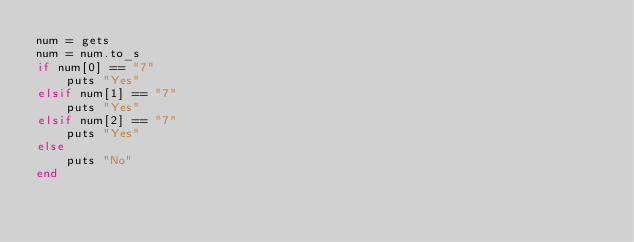<code> <loc_0><loc_0><loc_500><loc_500><_Ruby_>num = gets
num = num.to_s
if num[0] == "7"
    puts "Yes"
elsif num[1] == "7"
    puts "Yes"
elsif num[2] == "7"
    puts "Yes"
else
    puts "No"
end
</code> 